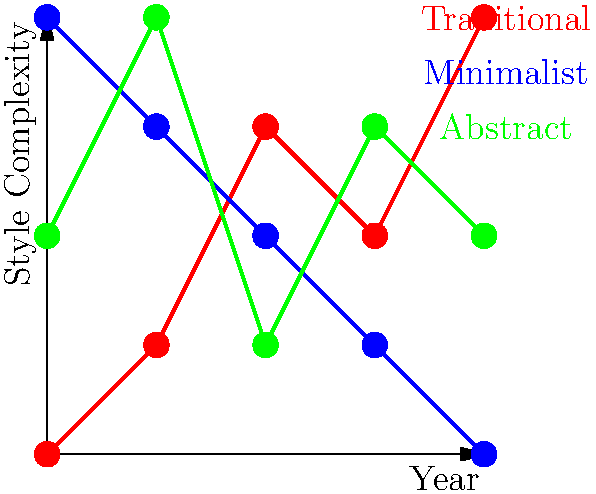Based on the graph showing the evolution of Depeche Mode album cover styles over time, which style would be most suitable for incorporating into a modern, edgy fashion line inspired by the band's later works? To answer this question, we need to analyze the trends shown in the graph for each album cover style:

1. Traditional style (red): Shows an overall increasing trend in complexity over time, indicating a move towards more intricate designs.

2. Minimalist style (blue): Demonstrates a decreasing trend in complexity, suggesting simpler, cleaner designs in later years.

3. Abstract style (green): Fluctuates over time but maintains a relatively consistent level of complexity.

For a modern, edgy fashion line inspired by Depeche Mode's later works, we should consider:

a) The most recent trends in the graph, which correspond to the band's later works.
b) The style that aligns best with contemporary fashion trends.
c) The potential for creating visually striking and unique designs.

The minimalist style (blue) shows the most pronounced trend in later years, with decreasing complexity. This aligns well with modern fashion trends that often favor clean, simple, and bold designs. Minimalist aesthetics are often associated with edginess and sophistication in contemporary fashion.

Moreover, minimalist designs are versatile and can be easily incorporated into various clothing items and accessories, making them ideal for a fashion line.

While the abstract style could also be suitable, its fluctuating nature might not provide as consistent a theme for a cohesive fashion line. The traditional style, becoming more complex over time, might be too intricate for a modern, edgy look.
Answer: Minimalist style 